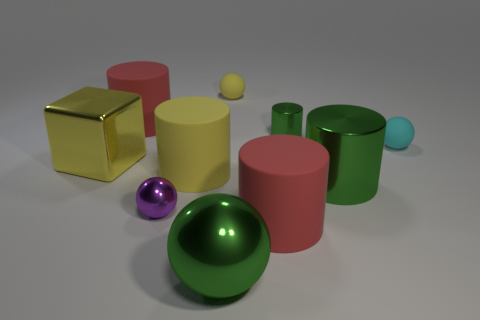Subtract all large green metallic balls. How many balls are left? 3 Subtract all brown spheres. How many red cylinders are left? 2 Subtract all green balls. How many balls are left? 3 Subtract all balls. How many objects are left? 6 Subtract 1 blocks. How many blocks are left? 0 Subtract all blue cylinders. Subtract all brown balls. How many cylinders are left? 5 Subtract all shiny spheres. Subtract all large blocks. How many objects are left? 7 Add 6 small cyan things. How many small cyan things are left? 7 Add 8 small green metallic objects. How many small green metallic objects exist? 9 Subtract 0 gray balls. How many objects are left? 10 